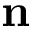Convert formula to latex. <formula><loc_0><loc_0><loc_500><loc_500>n</formula> 